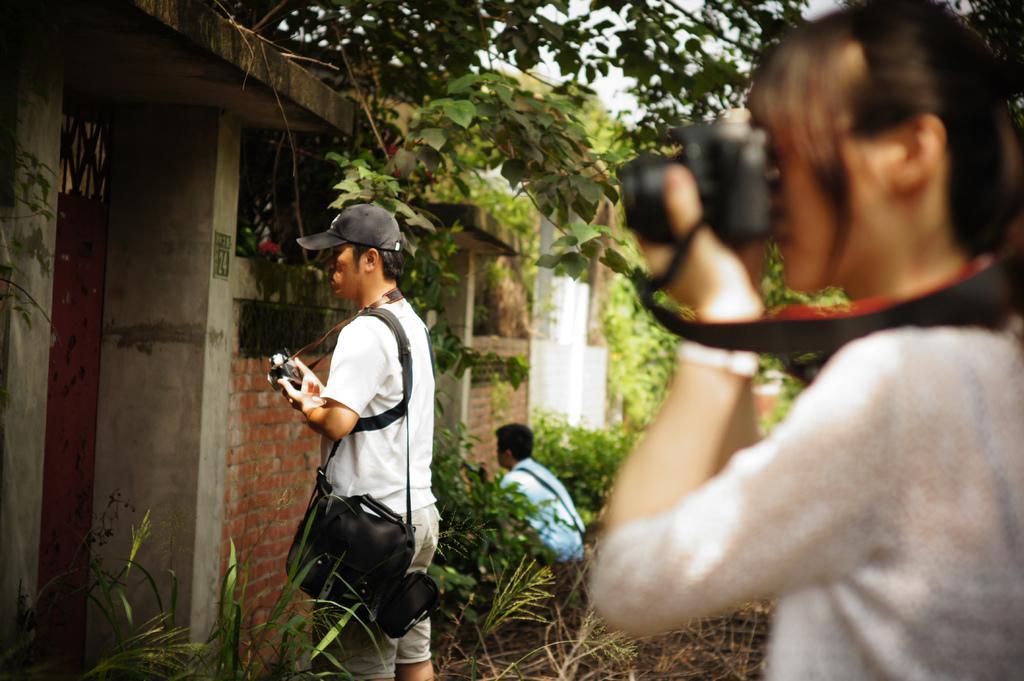Please provide a concise description of this image. In this image, in the front there is a woman standing and holding a camera and clicking a photo. In the center there is a man standing and holding a bag which is black in colour and holding a camera and wearing a black hat and there are plants in the center. In the background there are plants and there is a person and there are buildings. 